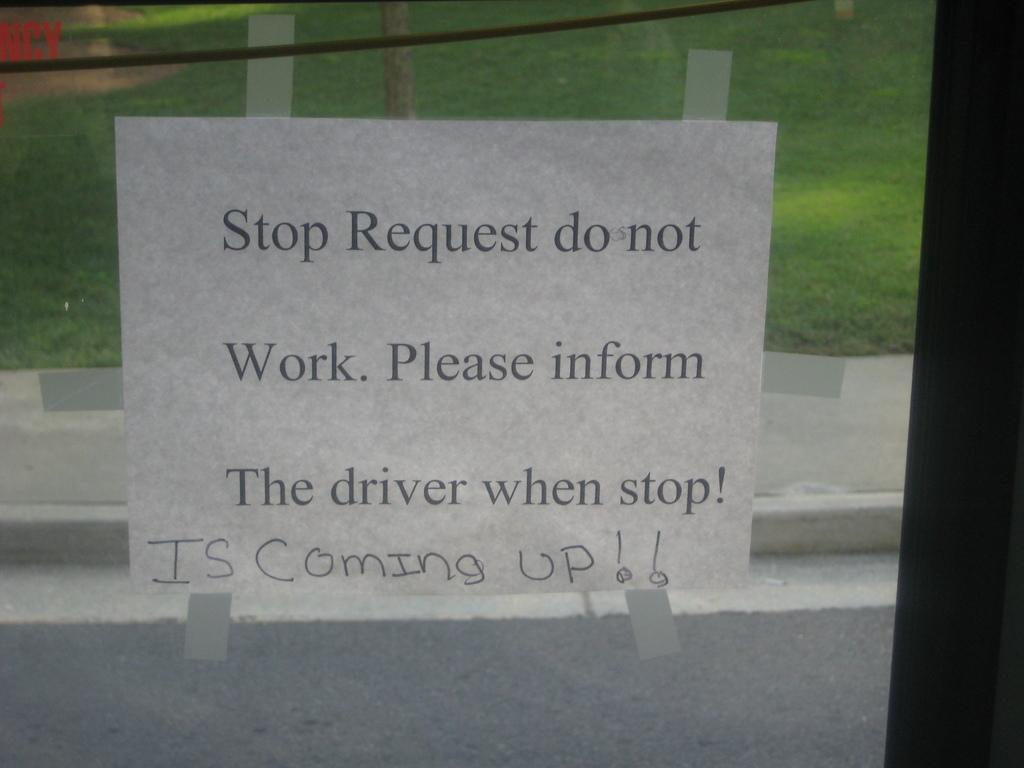Can you describe this image briefly? This picture shows a poster stuck on the glass and from the glass we see grass on the ground and a tree. 